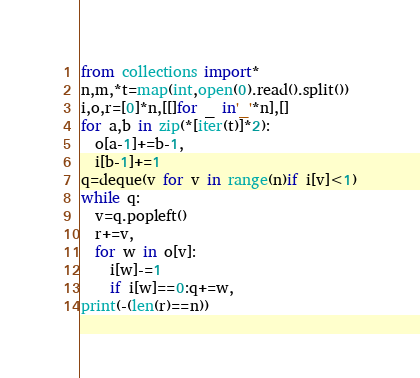<code> <loc_0><loc_0><loc_500><loc_500><_Python_>from collections import*
n,m,*t=map(int,open(0).read().split())
i,o,r=[0]*n,[[]for _ in'_'*n],[]
for a,b in zip(*[iter(t)]*2):
  o[a-1]+=b-1,
  i[b-1]+=1
q=deque(v for v in range(n)if i[v]<1)
while q:
  v=q.popleft()
  r+=v,
  for w in o[v]:
    i[w]-=1
    if i[w]==0:q+=w,
print(-(len(r)==n))</code> 